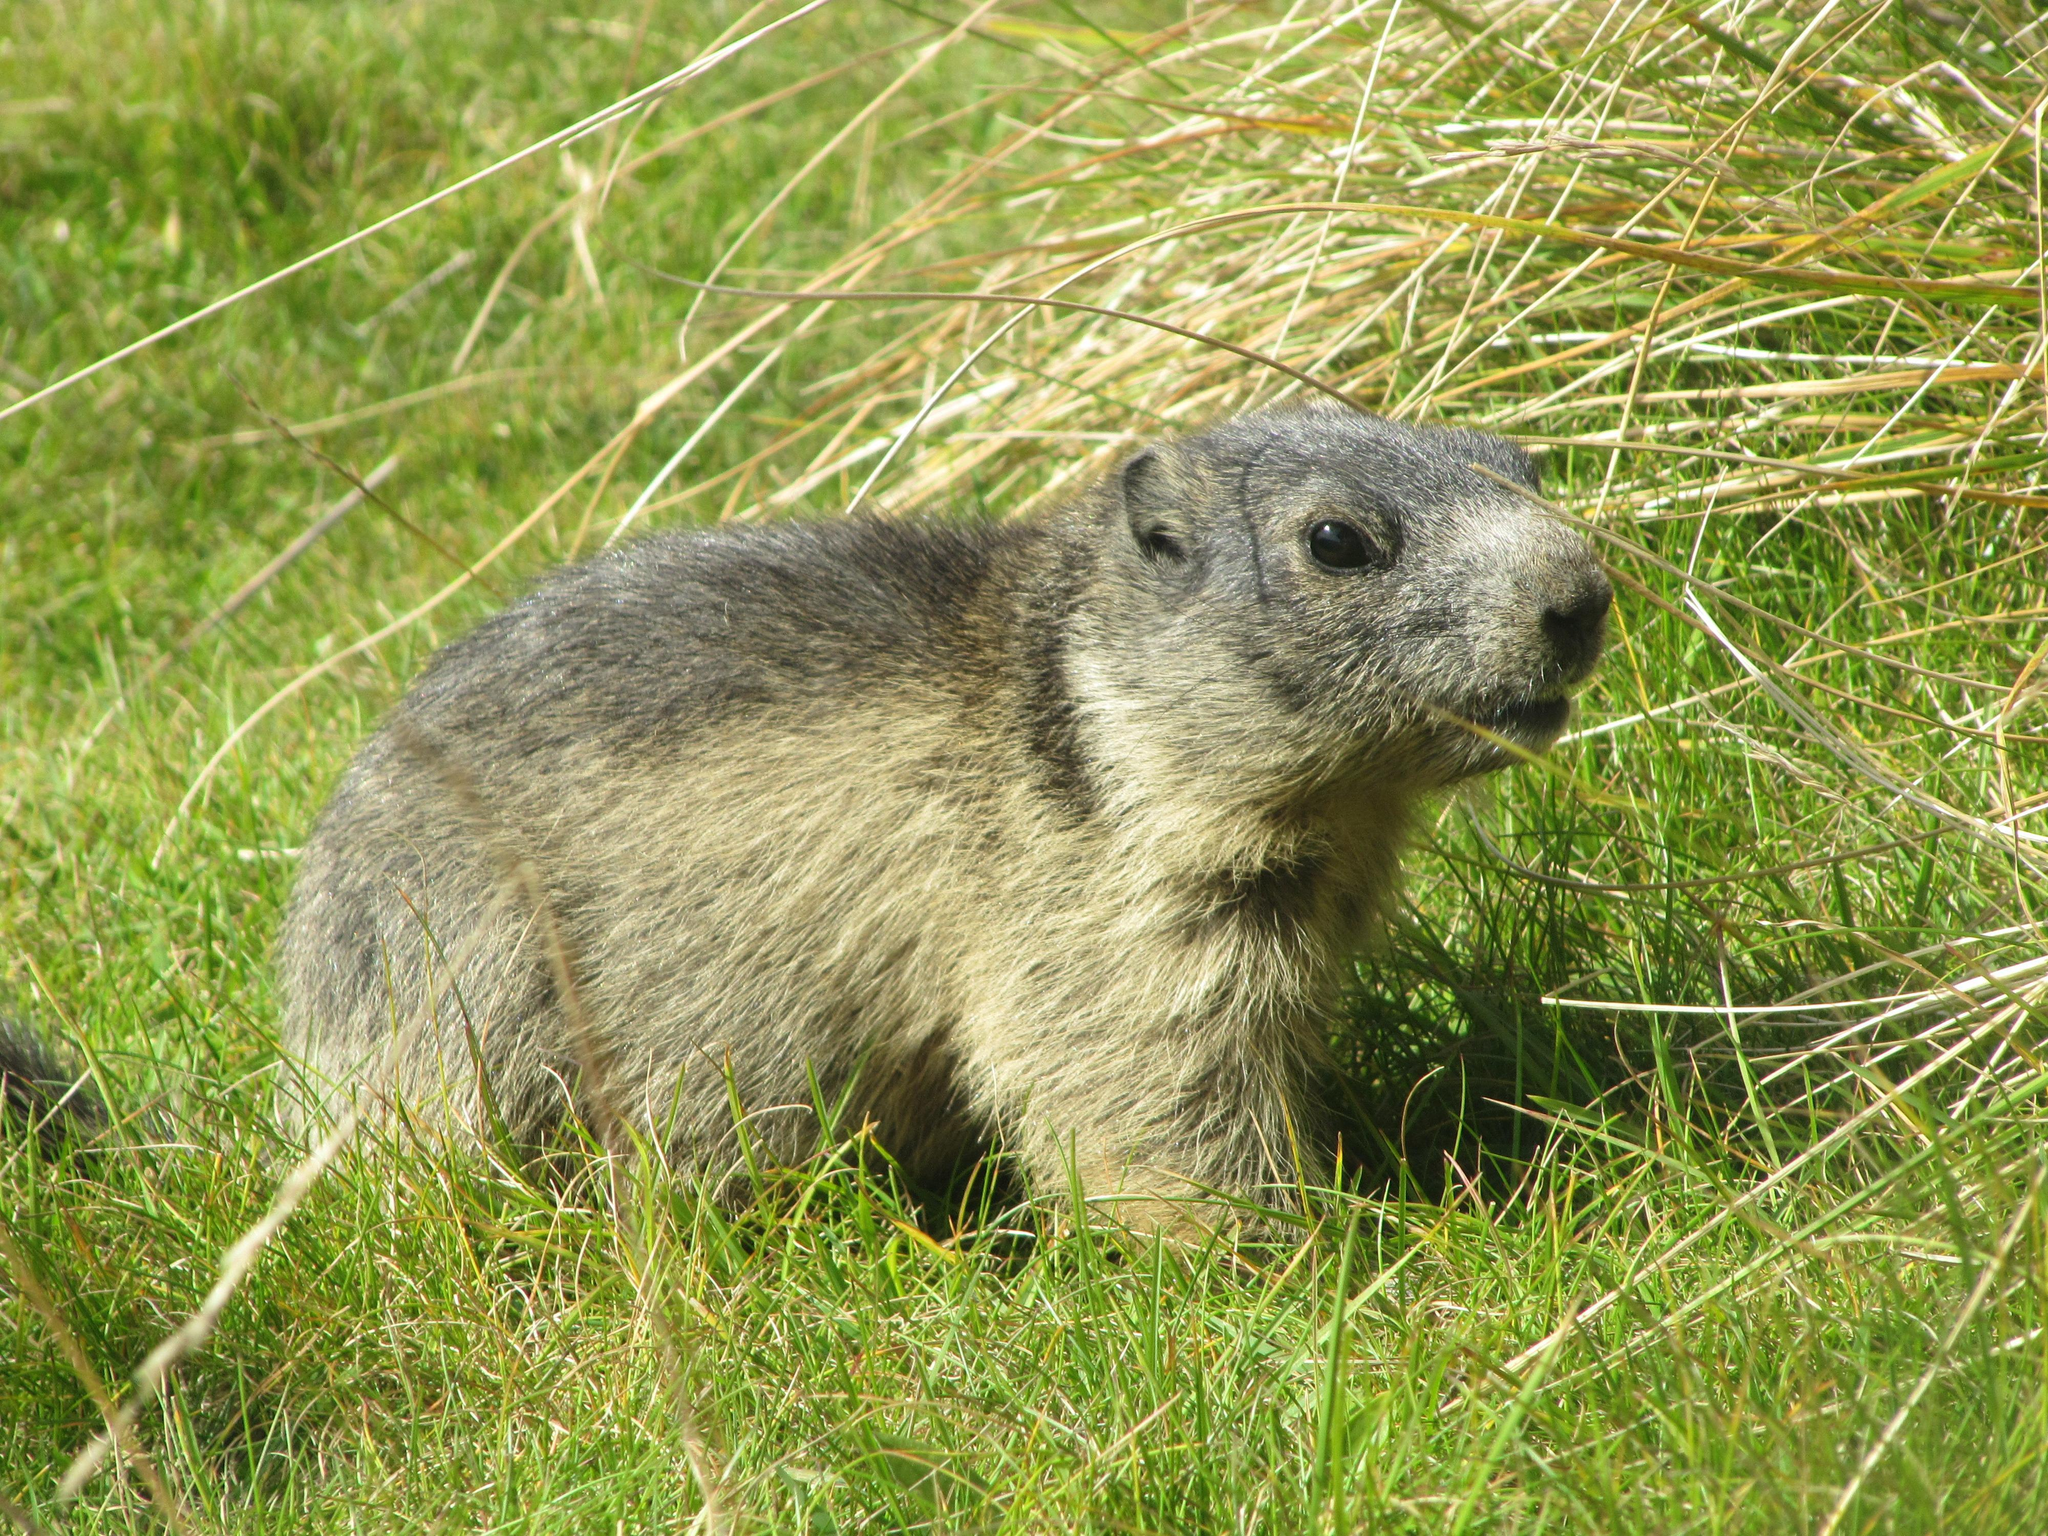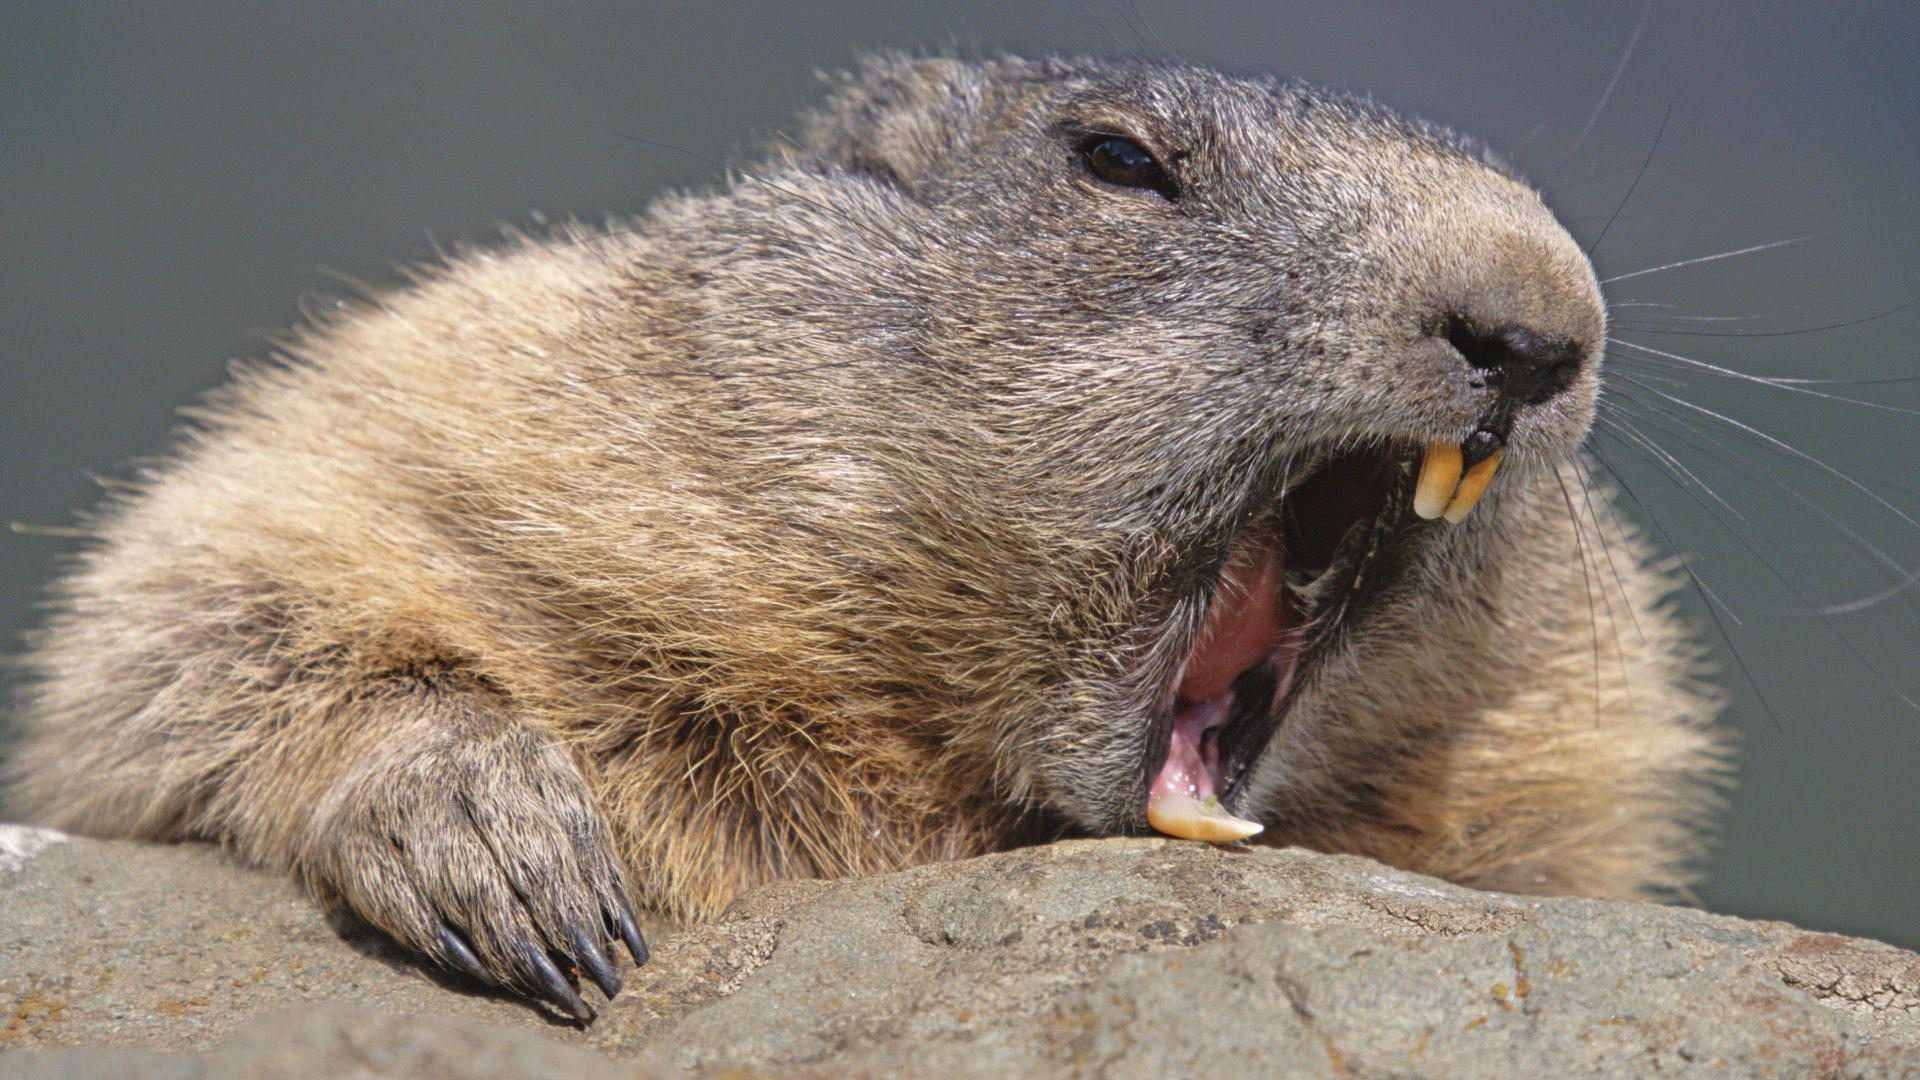The first image is the image on the left, the second image is the image on the right. Assess this claim about the two images: "In 1 of the images, 1 groundhog is holding an object with its forelimbs.". Correct or not? Answer yes or no. No. The first image is the image on the left, the second image is the image on the right. Examine the images to the left and right. Is the description "An image shows marmot with hands raised and close to each other." accurate? Answer yes or no. No. 